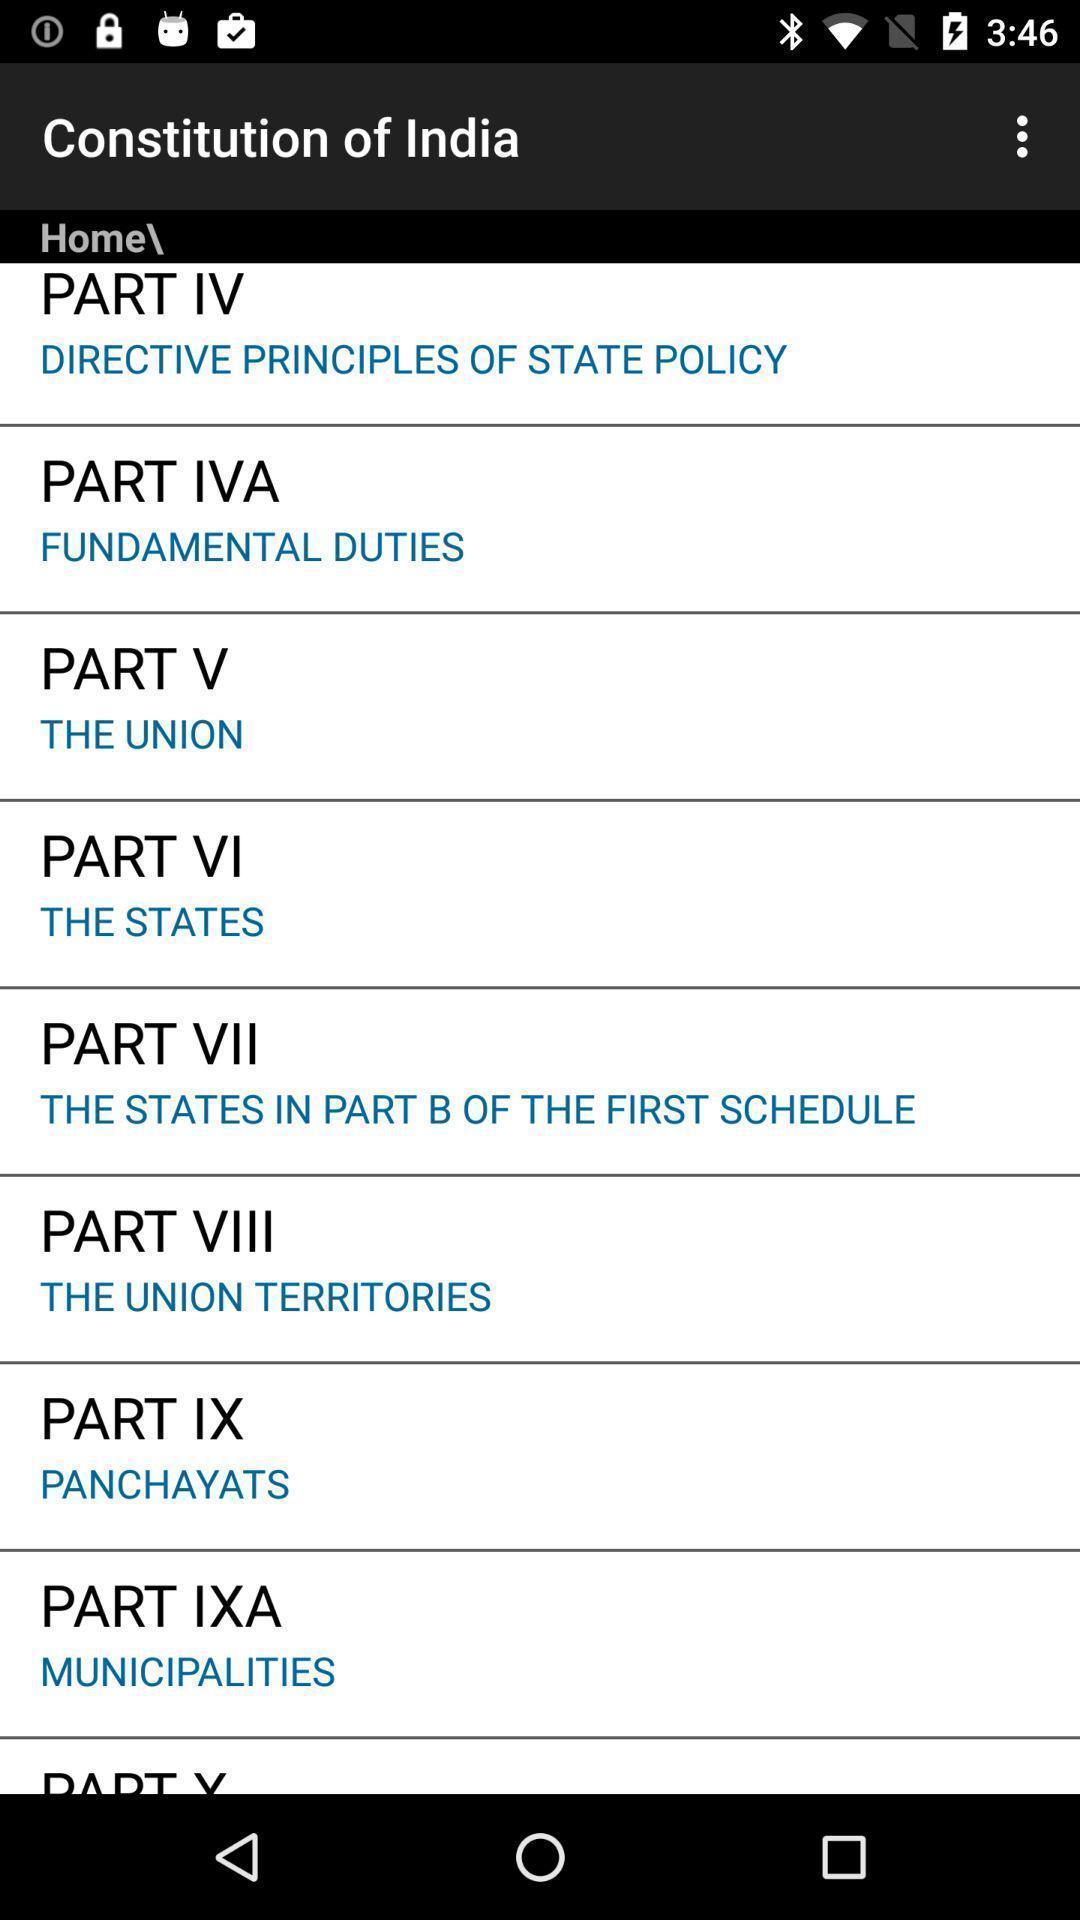What details can you identify in this image? Screen displaying the options in constitution tab. 